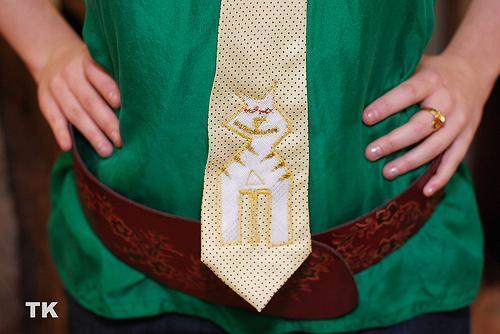How many rings are on the person's finger?
Give a very brief answer. 1. 